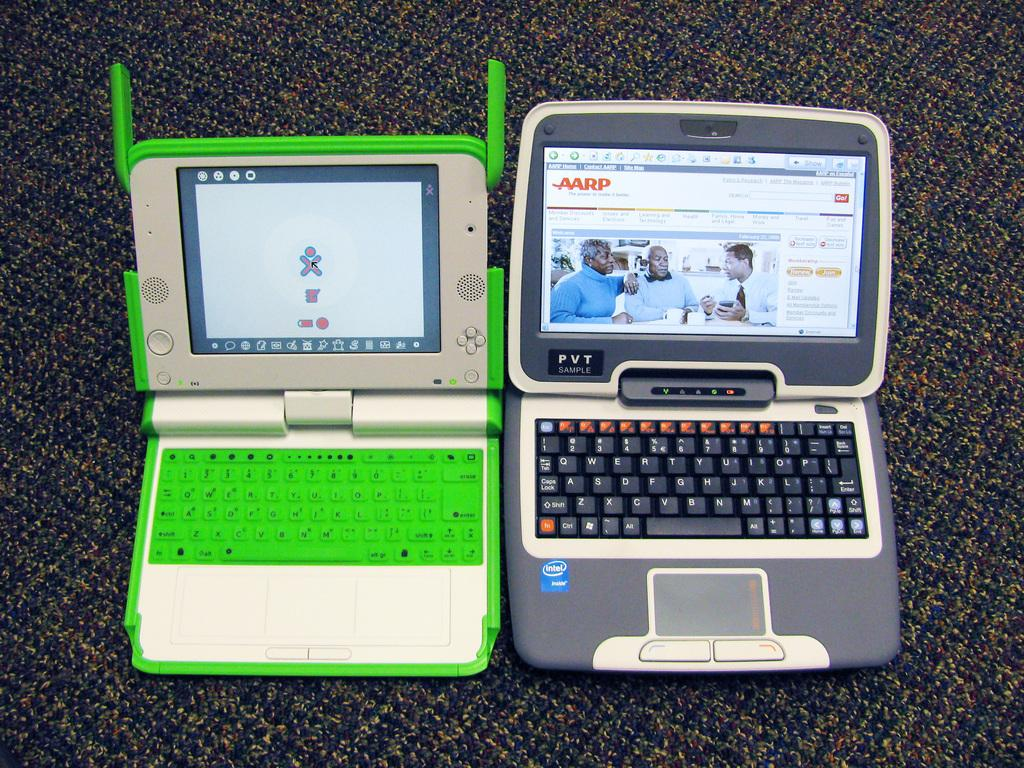Provide a one-sentence caption for the provided image. Two small laptops with one open to the AARP page. 